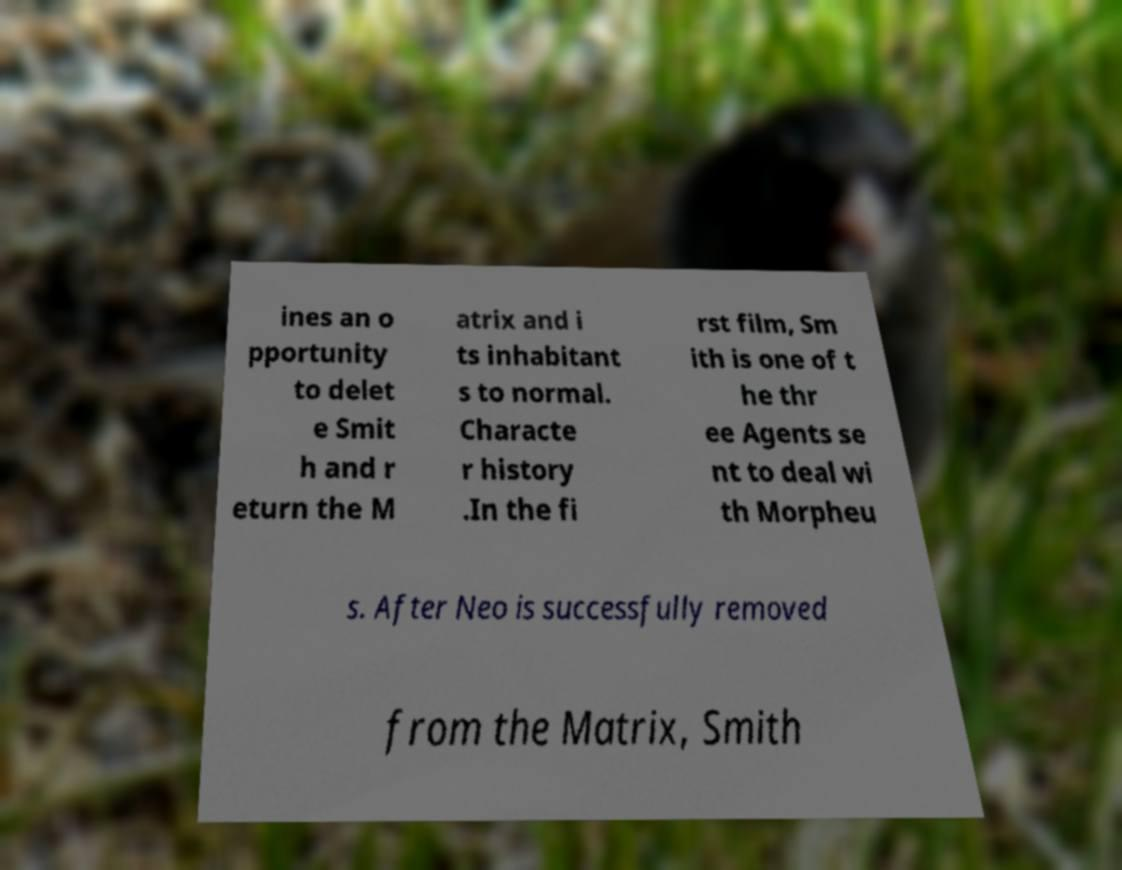Could you extract and type out the text from this image? ines an o pportunity to delet e Smit h and r eturn the M atrix and i ts inhabitant s to normal. Characte r history .In the fi rst film, Sm ith is one of t he thr ee Agents se nt to deal wi th Morpheu s. After Neo is successfully removed from the Matrix, Smith 